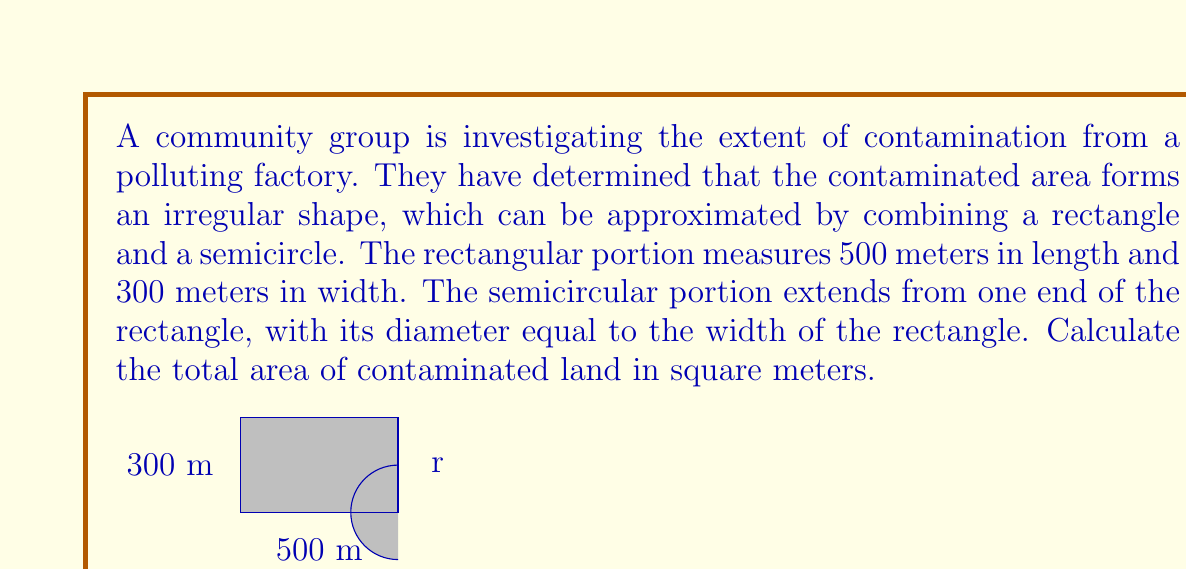Could you help me with this problem? To solve this problem, we need to calculate the areas of the rectangle and the semicircle separately, then add them together.

1. Area of the rectangle:
   $A_r = l \times w$
   where $l$ is length and $w$ is width
   $A_r = 500 \text{ m} \times 300 \text{ m} = 150,000 \text{ m}^2$

2. Area of the semicircle:
   The formula for the area of a circle is $A_c = \pi r^2$
   For a semicircle, we use half of this: $A_s = \frac{1}{2} \pi r^2$
   
   The diameter of the semicircle is equal to the width of the rectangle, so:
   $d = 300 \text{ m}$
   $r = \frac{d}{2} = 150 \text{ m}$

   Now we can calculate the area of the semicircle:
   $A_s = \frac{1}{2} \pi (150 \text{ m})^2 = \frac{1}{2} \pi (22,500 \text{ m}^2) = 35,342.92 \text{ m}^2$

3. Total contaminated area:
   $A_{\text{total}} = A_r + A_s$
   $A_{\text{total}} = 150,000 \text{ m}^2 + 35,342.92 \text{ m}^2 = 185,342.92 \text{ m}^2$

Therefore, the total area of contaminated land is approximately 185,342.92 square meters.
Answer: $185,342.92 \text{ m}^2$ 